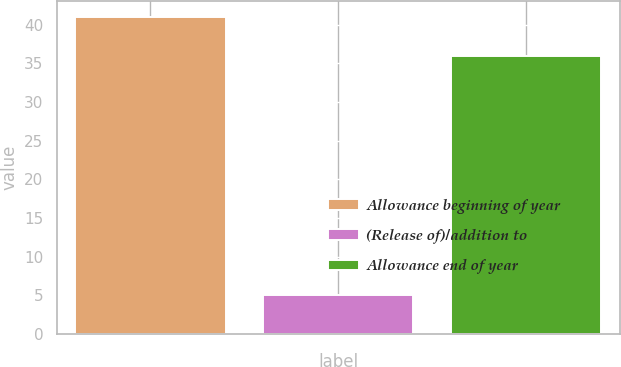Convert chart to OTSL. <chart><loc_0><loc_0><loc_500><loc_500><bar_chart><fcel>Allowance beginning of year<fcel>(Release of)/addition to<fcel>Allowance end of year<nl><fcel>41<fcel>5<fcel>36<nl></chart> 